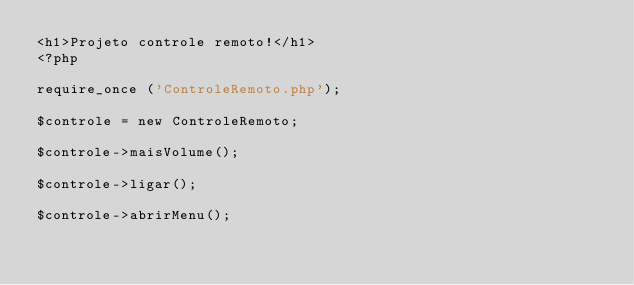Convert code to text. <code><loc_0><loc_0><loc_500><loc_500><_PHP_><h1>Projeto controle remoto!</h1>
<?php

require_once ('ControleRemoto.php');

$controle = new ControleRemoto;

$controle->maisVolume();

$controle->ligar();

$controle->abrirMenu();
</code> 